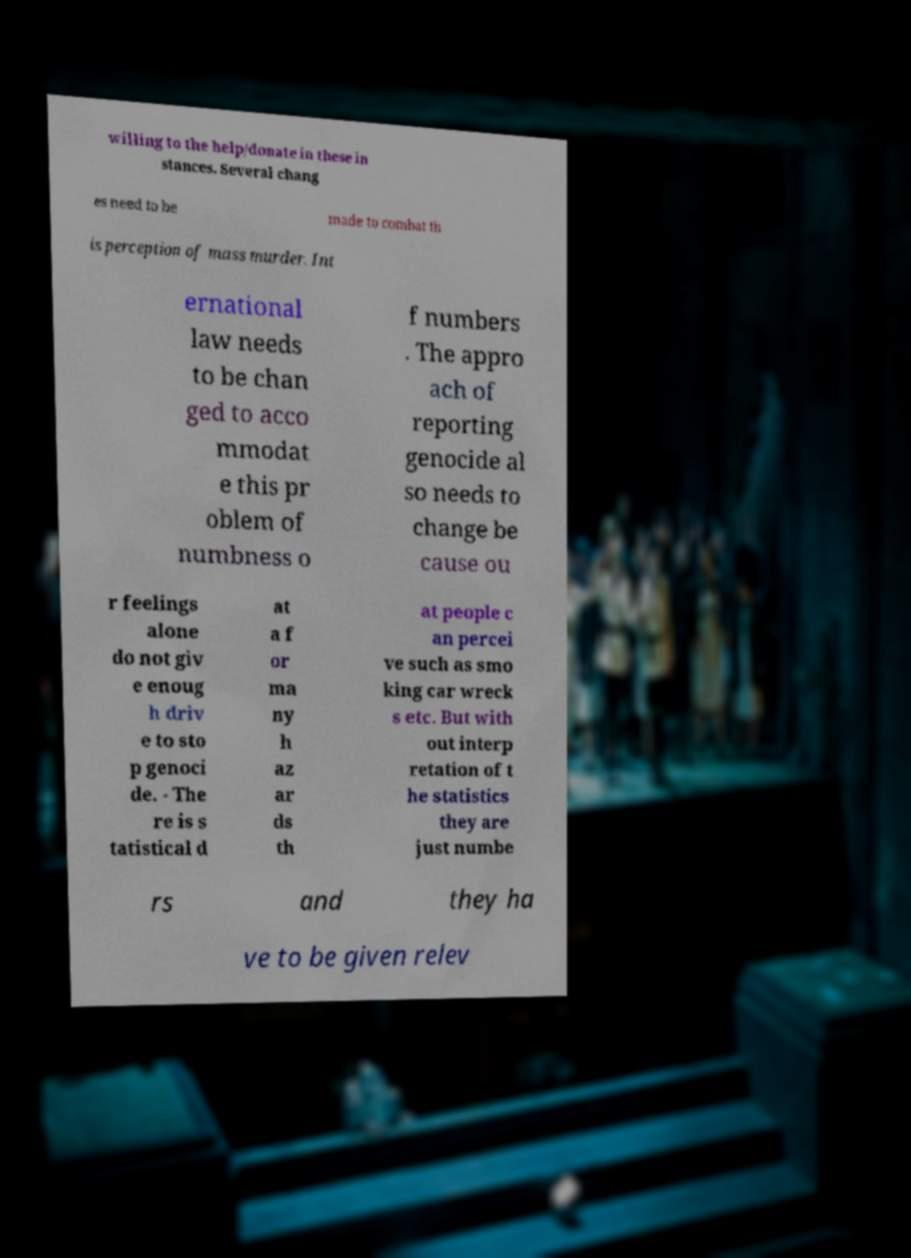Can you accurately transcribe the text from the provided image for me? willing to the help/donate in these in stances. Several chang es need to be made to combat th is perception of mass murder. Int ernational law needs to be chan ged to acco mmodat e this pr oblem of numbness o f numbers . The appro ach of reporting genocide al so needs to change be cause ou r feelings alone do not giv e enoug h driv e to sto p genoci de. - The re is s tatistical d at a f or ma ny h az ar ds th at people c an percei ve such as smo king car wreck s etc. But with out interp retation of t he statistics they are just numbe rs and they ha ve to be given relev 